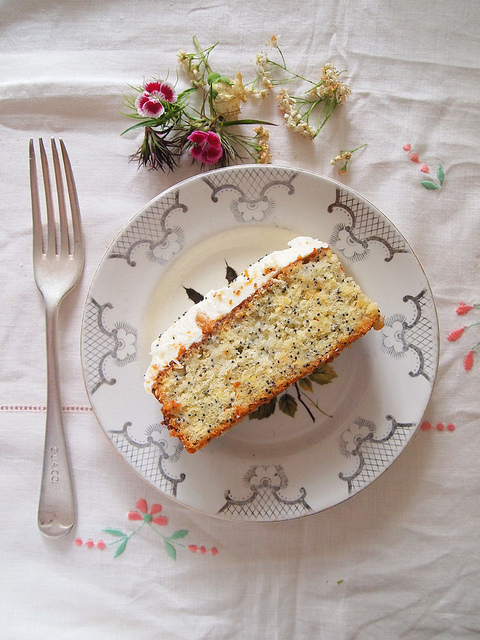In which direction is the fork placed relative to the plate? The fork is conveniently placed to the left of the plate, ensuring easy access for either right-handed or left-handed individuals. 